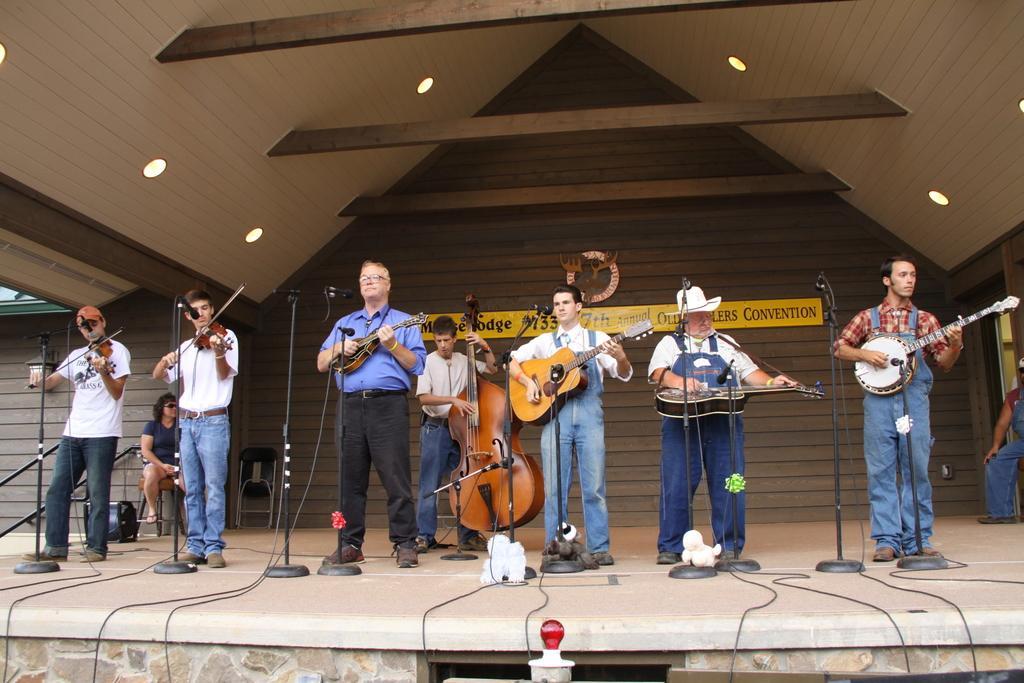How would you summarize this image in a sentence or two? In this image we can see a group of people standing and playing a musical instrument. At the back side there is a building. 